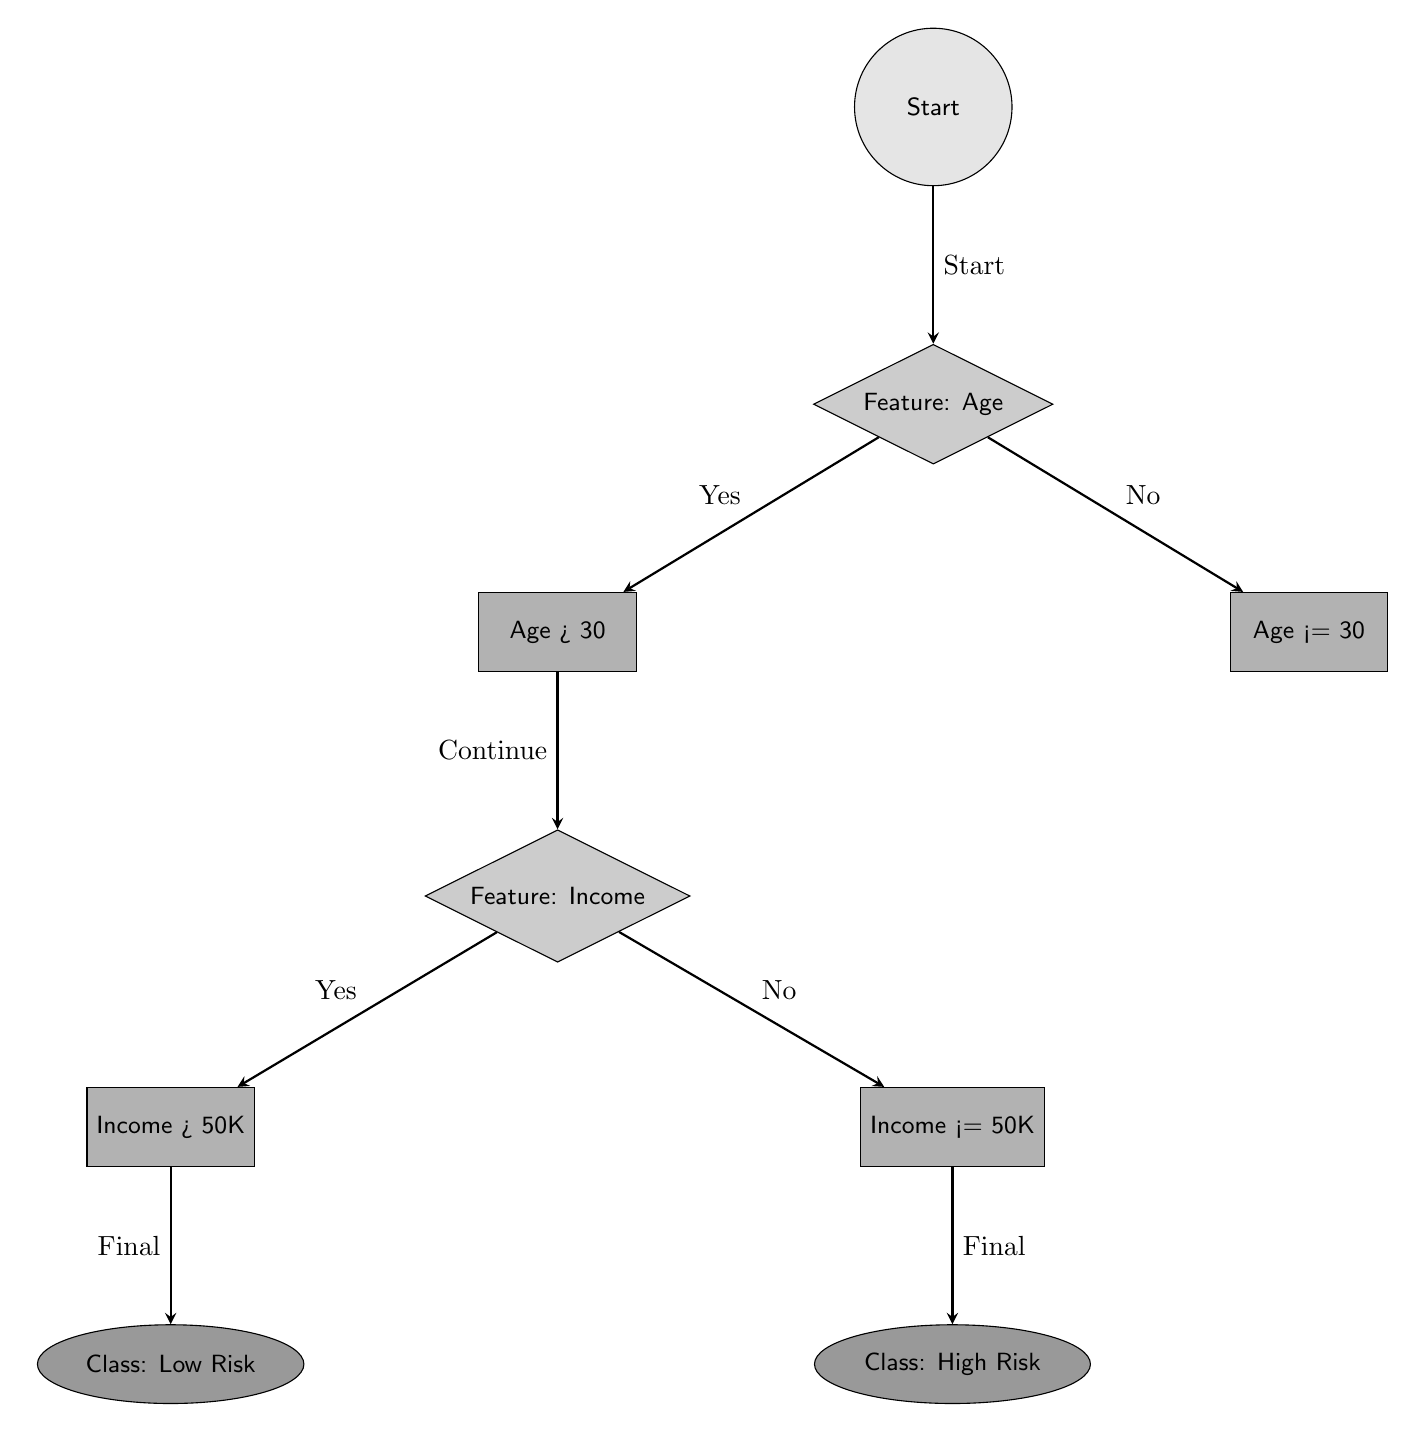What is the starting point of the flow? The flow begins at the node labeled "Start," which indicates the entry into the decision-making process.
Answer: Start What feature is being evaluated after the start? The node immediately below the "Start" node is labeled "Feature: Age," indicating that the next step involves examining the age of individuals.
Answer: Feature: Age What condition is tested for age? The decision node for age asks whether "Age > 30," which is the comparison made for branching in the flow.
Answer: Age > 30 How many final class outcomes are there in this flow? The diagram shows two distinct outcomes for classes based on the decisions made: "Class: Low Risk" and "Class: High Risk."
Answer: 2 If a person is 25 years old with an income of 40K, what is the class assigned? First, the decision for age is "No" since 25 is not greater than 30, leading to the right node where there is an evaluation of income. Since 40K is less than or equal to 50K, the next decision assigns the class as "High Risk."
Answer: Class: High Risk Which node comes after "Income > 50K"? The node following "Income > 50K" below the left side of the tree leads directly to the class outcome "Class: Low Risk."
Answer: Class: Low Risk What type of nodes are used to represent the decision points in this flow? The decision points are represented by diamond-shaped nodes, which conventionally indicate branching decisions based on evaluations of certain features or conditions.
Answer: Diamond What is indicated by reaching "Final" in the diagram? The term "Final" signifies that the algorithm has reached a terminal node where a classification outcome (either "Low Risk" or "High Risk") is designated, concluding the decision-making process.
Answer: Final 